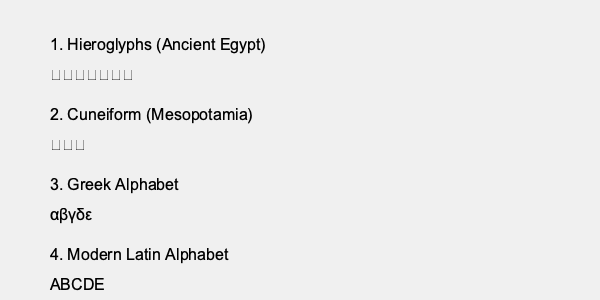As a historical novel author imagining past lives, analyze the progression of writing systems shown in the image. Which characteristic best describes the evolution from ancient to modern scripts, and how might this impact the way characters in different historical periods perceive and interact with written language? To answer this question, we need to examine the progression of writing systems shown in the image and identify the key characteristic that describes their evolution:

1. Hieroglyphs (Ancient Egypt):
   - Pictorial and symbolic representation of objects and concepts
   - Complex system with numerous characters
   - Requires extensive knowledge to read and write

2. Cuneiform (Mesopotamia):
   - Wedge-shaped characters pressed into clay
   - Still complex but more abstract than hieroglyphs
   - Represents syllables and concepts

3. Greek Alphabet:
   - Simpler system with fewer characters
   - Each character represents a specific sound (phonetic)
   - More accessible for learning and widespread use

4. Modern Latin Alphabet:
   - Further simplification and standardization
   - Purely phonetic representation
   - Highly adaptable to different languages

The key characteristic in this evolution is the progression from complex, pictorial representations to simpler, more abstract phonetic symbols. This shift towards abstraction and simplification made writing systems more accessible and easier to learn, leading to increased literacy rates over time.

Impact on characters in different historical periods:

1. Ancient Egyptian era: Characters would view writing as a sacred, complex art form, limited to scribes and elites. They might perceive texts as having magical properties.

2. Mesopotamian era: Writing becomes more utilitarian, used for record-keeping and communication. Characters might see it as a valuable skill for merchants and administrators.

3. Ancient Greek era: The simpler alphabet allows for more widespread literacy. Characters might engage in philosophical debates through written works and value education more highly.

4. Modern era: Characters would take literacy for granted, with writing being an essential part of daily life. They might struggle to imagine a world without easy access to written information.

This progression impacts how characters interact with written language, moving from reverence and exclusivity to everyday utility and widespread accessibility.
Answer: Progression from complex pictorial representations to simpler, abstract phonetic symbols, leading to increased accessibility and literacy. 